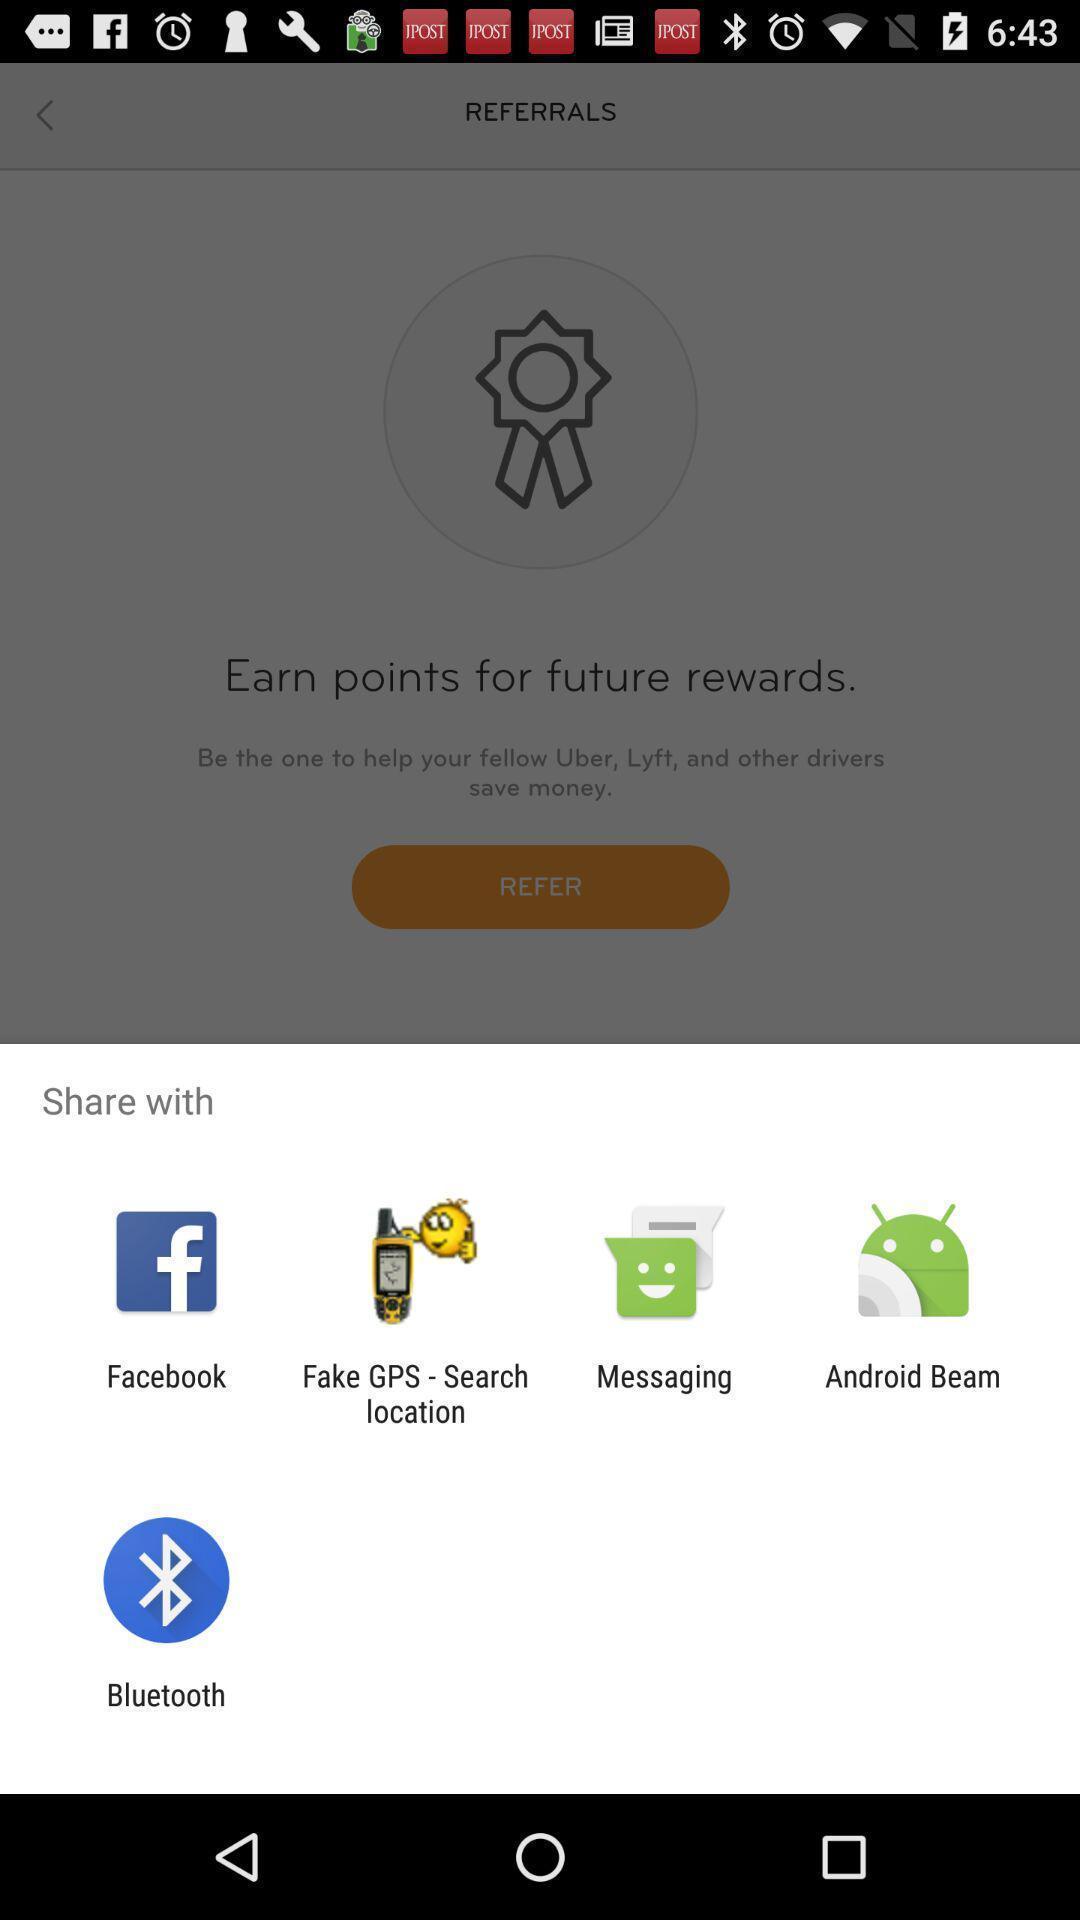What can you discern from this picture? Popup of applications to share the information. 